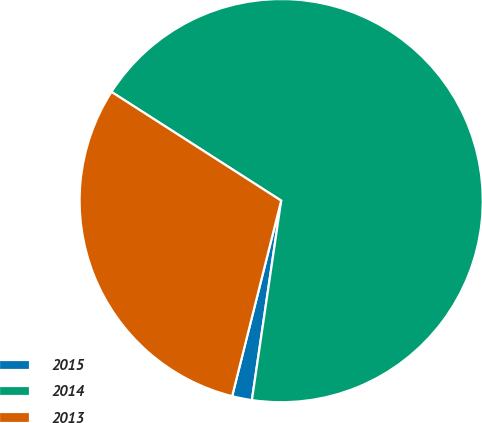<chart> <loc_0><loc_0><loc_500><loc_500><pie_chart><fcel>2015<fcel>2014<fcel>2013<nl><fcel>1.59%<fcel>68.25%<fcel>30.16%<nl></chart> 